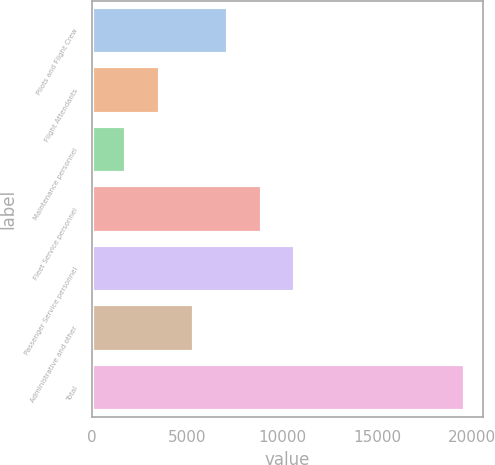Convert chart to OTSL. <chart><loc_0><loc_0><loc_500><loc_500><bar_chart><fcel>Pilots and Flight Crew<fcel>Flight Attendants<fcel>Maintenance personnel<fcel>Fleet Service personnel<fcel>Passenger Service personnel<fcel>Administrative and other<fcel>Total<nl><fcel>7140<fcel>3580<fcel>1800<fcel>8920<fcel>10700<fcel>5360<fcel>19600<nl></chart> 